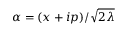<formula> <loc_0><loc_0><loc_500><loc_500>\alpha = ( x + i p ) / \sqrt { 2 \lambda }</formula> 